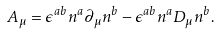<formula> <loc_0><loc_0><loc_500><loc_500>A _ { \mu } = \epsilon ^ { a b } n ^ { a } \partial _ { \mu } n ^ { b } - \epsilon ^ { a b } n ^ { a } D _ { \mu } n ^ { b } .</formula> 